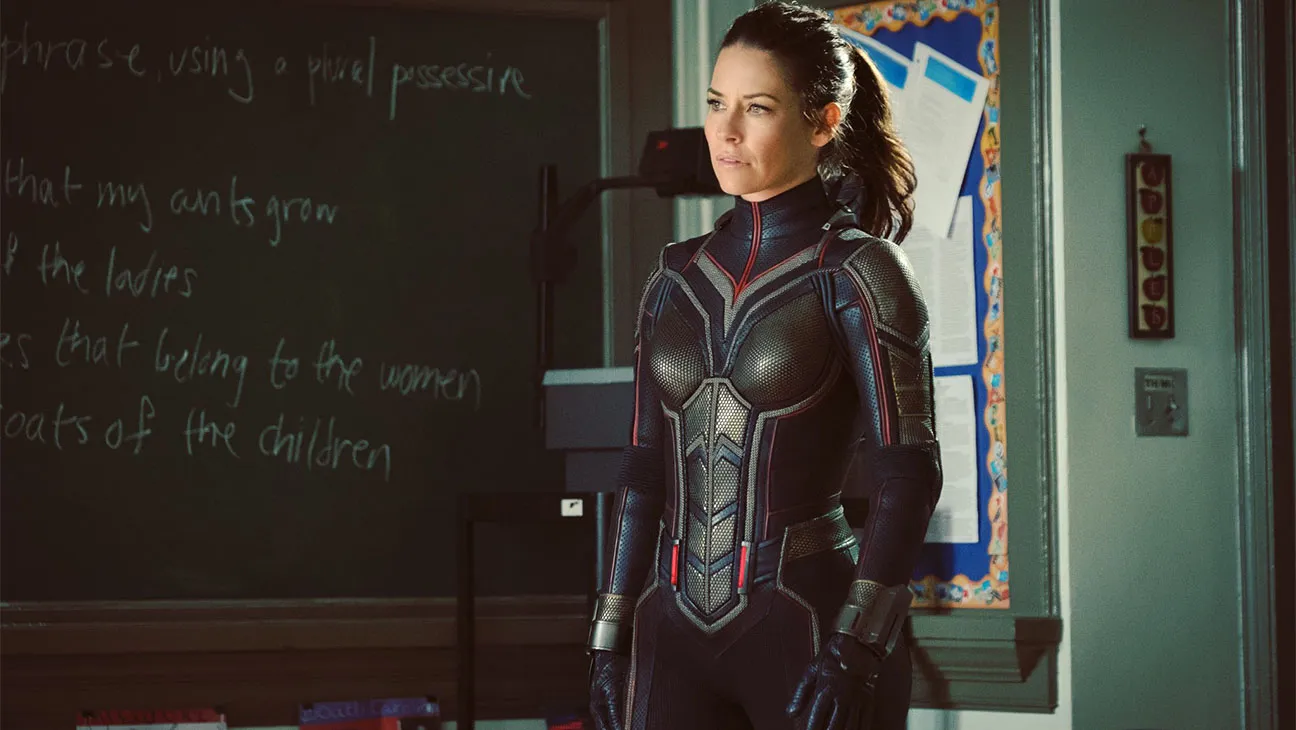What emotions do you think the character is experiencing? The character seems to be experiencing a mix of determination and concern. Her focused and serious expression suggests that she is in the midst of a critical situation that requires her full attention and resolve. Why do you think the setting is a classroom? The setting appears to be a classroom due to several elements in the background: the chalkboard with writing, the bulletin board with papers and drawings, and the overall layout and decor typical of an educational environment. This could imply the character is in the midst of a mission that involves younger individuals or educational themes. 